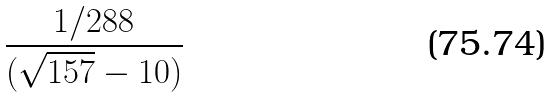Convert formula to latex. <formula><loc_0><loc_0><loc_500><loc_500>\frac { 1 / 2 8 8 } { ( \sqrt { 1 5 7 } - 1 0 ) }</formula> 